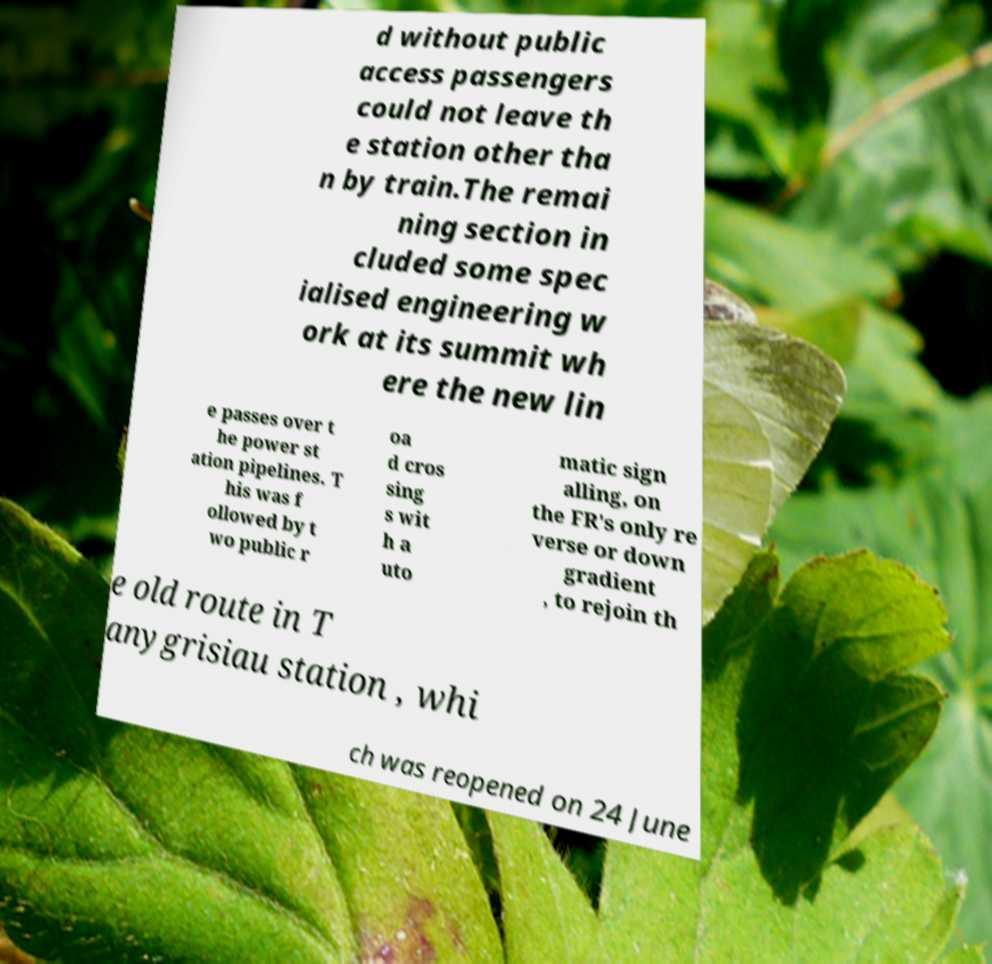Please identify and transcribe the text found in this image. d without public access passengers could not leave th e station other tha n by train.The remai ning section in cluded some spec ialised engineering w ork at its summit wh ere the new lin e passes over t he power st ation pipelines. T his was f ollowed by t wo public r oa d cros sing s wit h a uto matic sign alling, on the FR's only re verse or down gradient , to rejoin th e old route in T anygrisiau station , whi ch was reopened on 24 June 